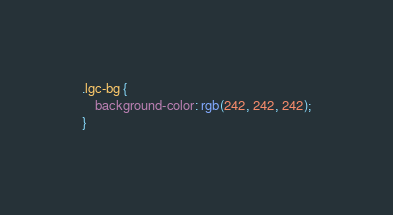<code> <loc_0><loc_0><loc_500><loc_500><_CSS_>.lgc-bg {
    background-color: rgb(242, 242, 242);
}</code> 